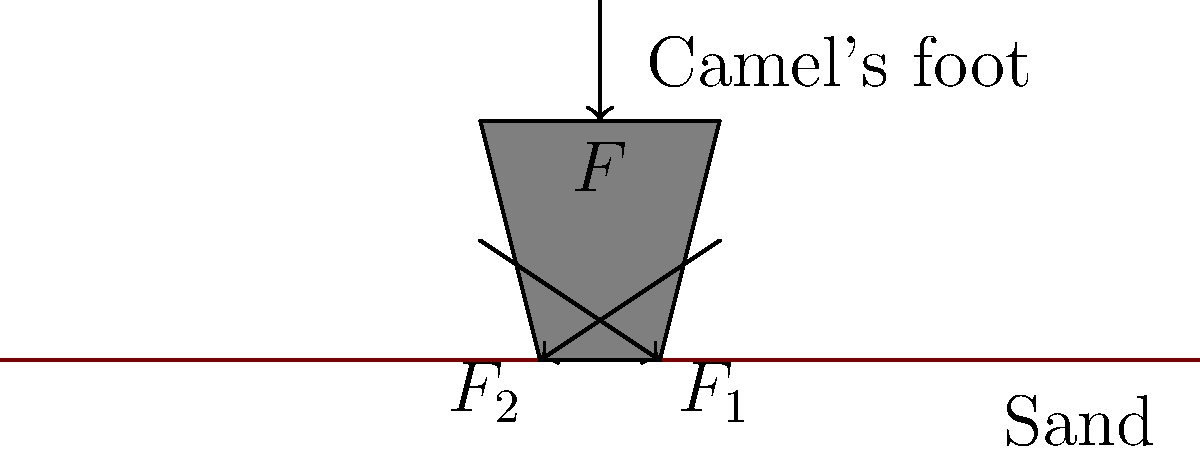As you observe a camel walking across the desert, you notice its feet don't sink into the sand. How does the shape of a camel's foot contribute to the distribution of forces that prevents it from sinking? Consider the total downward force $F$ and the resulting forces $F_1$ and $F_2$ on the sides of the foot. 1. The camel's foot has a unique shape that spreads out when it touches the ground, increasing the surface area in contact with the sand.

2. The total downward force $F$ from the camel's weight is distributed across this larger surface area.

3. This distribution creates two main component forces, $F_1$ and $F_2$, which act on the sides of the foot.

4. These forces can be represented as vectors pointing outward and slightly downward.

5. The horizontal components of $F_1$ and $F_2$ push the sand outward, compressing it and creating a firmer surface.

6. The vertical components of $F_1$ and $F_2$ support the camel's weight.

7. The relationship between these forces can be expressed as:
   $$F = F_1 \sin{\theta_1} + F_2 \sin{\theta_2}$$
   where $\theta_1$ and $\theta_2$ are the angles between the forces and the horizontal.

8. This distribution of forces over a larger area reduces the pressure on any single point of the sand, preventing the foot from sinking.

9. The compressed sand around the foot also provides additional support, further preventing sinking.
Answer: The camel's foot spreads out, distributing the weight over a larger area and creating outward forces that compress the sand, reducing pressure and preventing sinking. 